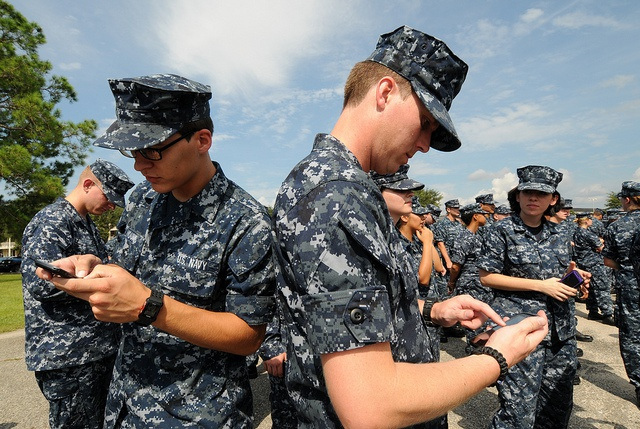Describe the objects in this image and their specific colors. I can see people in green, black, gray, and tan tones, people in green, black, gray, maroon, and darkgray tones, people in green, black, gray, darkgray, and darkblue tones, people in green, black, gray, and darkgray tones, and people in green, black, gray, darkgray, and purple tones in this image. 